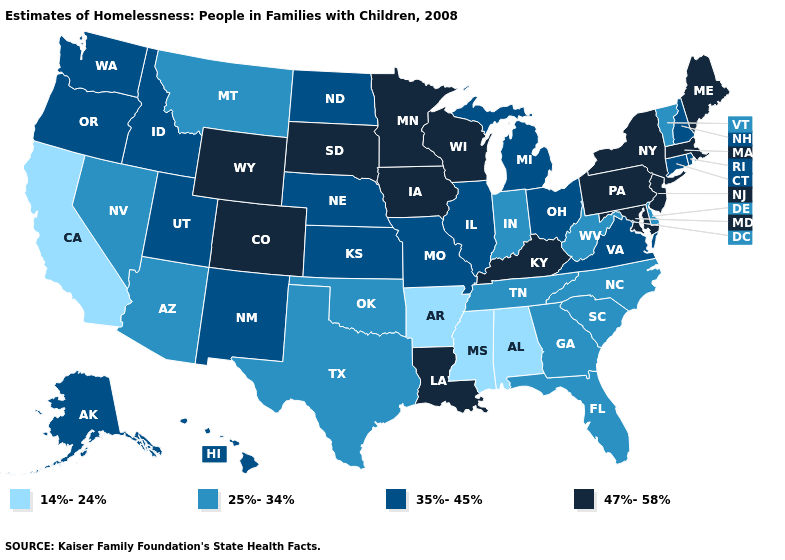Does Massachusetts have a higher value than New Jersey?
Give a very brief answer. No. What is the highest value in states that border Vermont?
Concise answer only. 47%-58%. What is the value of Arkansas?
Write a very short answer. 14%-24%. Does the first symbol in the legend represent the smallest category?
Quick response, please. Yes. Name the states that have a value in the range 14%-24%?
Concise answer only. Alabama, Arkansas, California, Mississippi. What is the value of Pennsylvania?
Short answer required. 47%-58%. What is the lowest value in the Northeast?
Be succinct. 25%-34%. Among the states that border Idaho , which have the lowest value?
Give a very brief answer. Montana, Nevada. Name the states that have a value in the range 14%-24%?
Answer briefly. Alabama, Arkansas, California, Mississippi. Which states hav the highest value in the Northeast?
Keep it brief. Maine, Massachusetts, New Jersey, New York, Pennsylvania. Name the states that have a value in the range 47%-58%?
Give a very brief answer. Colorado, Iowa, Kentucky, Louisiana, Maine, Maryland, Massachusetts, Minnesota, New Jersey, New York, Pennsylvania, South Dakota, Wisconsin, Wyoming. What is the value of Kentucky?
Concise answer only. 47%-58%. What is the lowest value in the USA?
Quick response, please. 14%-24%. Among the states that border North Dakota , which have the lowest value?
Keep it brief. Montana. Which states have the lowest value in the USA?
Answer briefly. Alabama, Arkansas, California, Mississippi. 